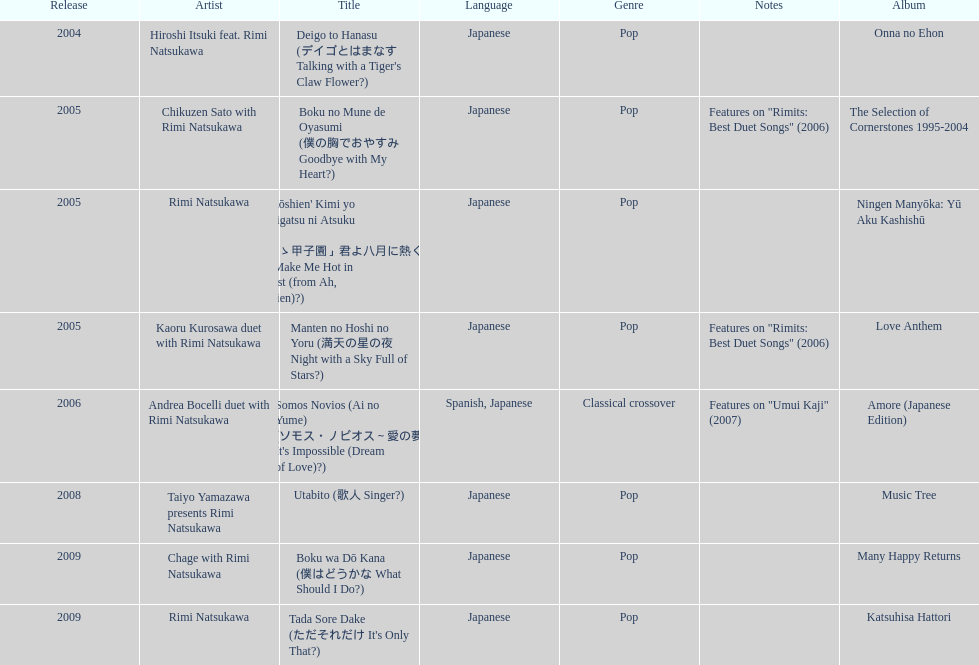Which was released earlier, deigo to hanasu or utabito? Deigo to Hanasu. 